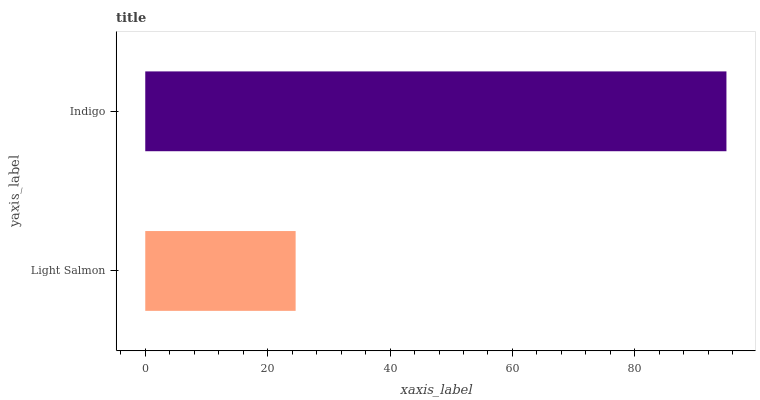Is Light Salmon the minimum?
Answer yes or no. Yes. Is Indigo the maximum?
Answer yes or no. Yes. Is Indigo the minimum?
Answer yes or no. No. Is Indigo greater than Light Salmon?
Answer yes or no. Yes. Is Light Salmon less than Indigo?
Answer yes or no. Yes. Is Light Salmon greater than Indigo?
Answer yes or no. No. Is Indigo less than Light Salmon?
Answer yes or no. No. Is Indigo the high median?
Answer yes or no. Yes. Is Light Salmon the low median?
Answer yes or no. Yes. Is Light Salmon the high median?
Answer yes or no. No. Is Indigo the low median?
Answer yes or no. No. 